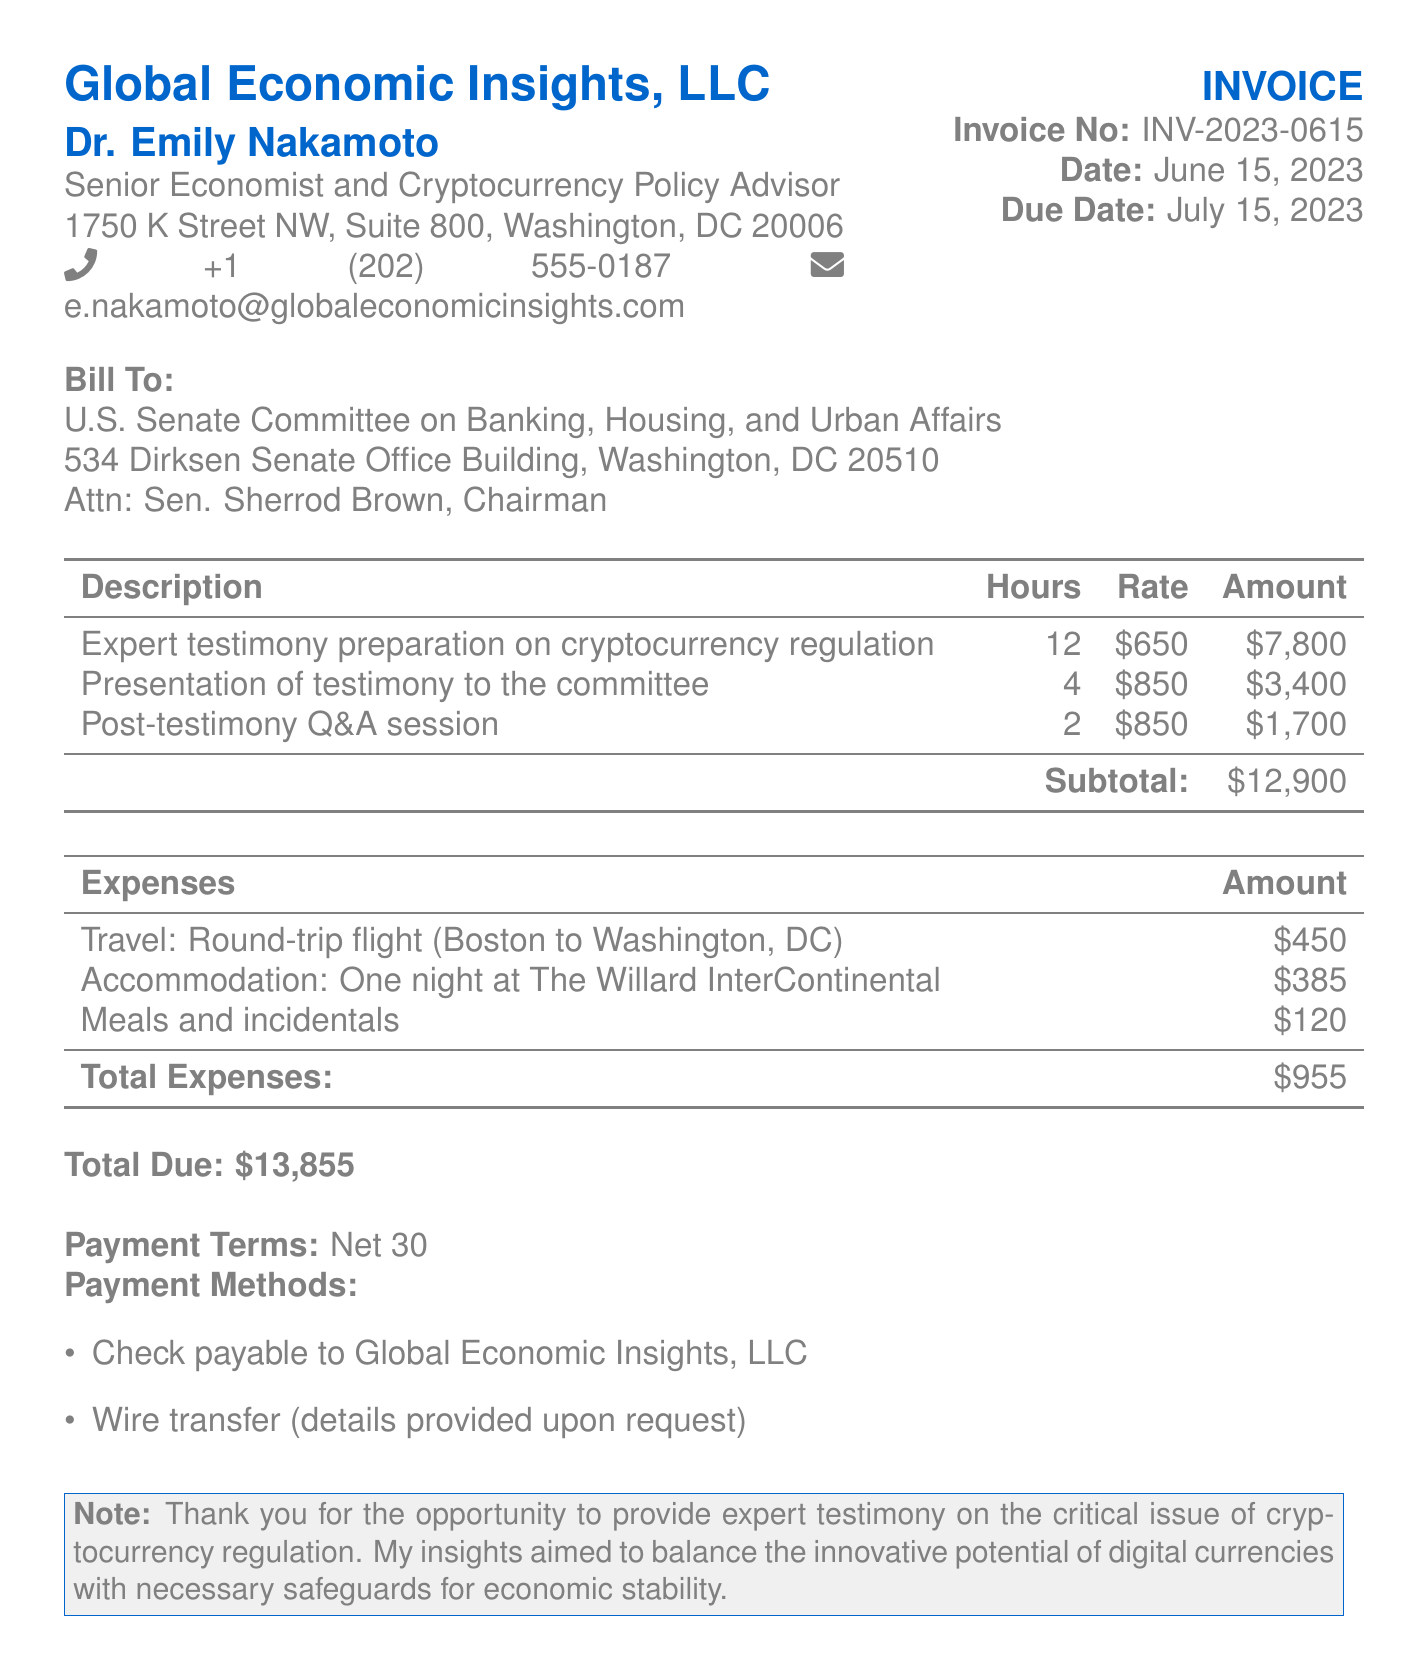What is the name of the company issuing the invoice? The invoice is issued by Global Economic Insights, LLC, as mentioned at the top of the document.
Answer: Global Economic Insights, LLC Who is the recipient of the invoice? The bill is addressed to the U.S. Senate Committee on Banking, Housing, and Urban Affairs, located in Washington, DC.
Answer: U.S. Senate Committee on Banking, Housing, and Urban Affairs What is the date the invoice was issued? The date of the invoice is specified in the document as June 15, 2023.
Answer: June 15, 2023 What is the total amount due on the invoice? The total due is calculated by adding the subtotal and total expenses, which is $12,900 + $955.
Answer: $13,855 How many hours were billed for expert testimony preparation? The document states that 12 hours were billed specifically for expert testimony preparation.
Answer: 12 What is the hourly rate for the presentation of testimony? The rate for presenting testimony to the committee is provided as $850 per hour.
Answer: $850 What is the total amount billed for post-testimony Q&A? The total amount for the post-testimony Q&A session is calculated as 2 hours at a rate of $850, equating to $1,700.
Answer: $1,700 What is the payment term stated in the invoice? The payment terms referenced in the document indicate "Net 30."
Answer: Net 30 What type of expenses are itemized in the document? The document lists travel, accommodation, and meals as types of expenses incurred.
Answer: Travel, accommodation, meals 